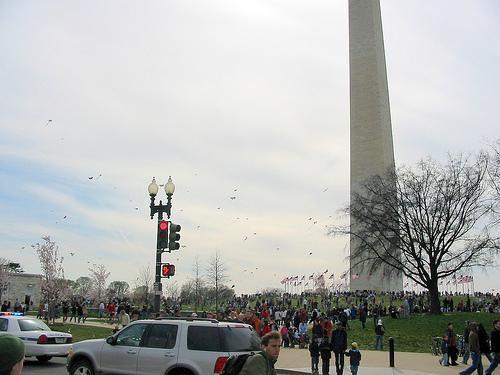How many police cars are there?
Give a very brief answer. 1. 